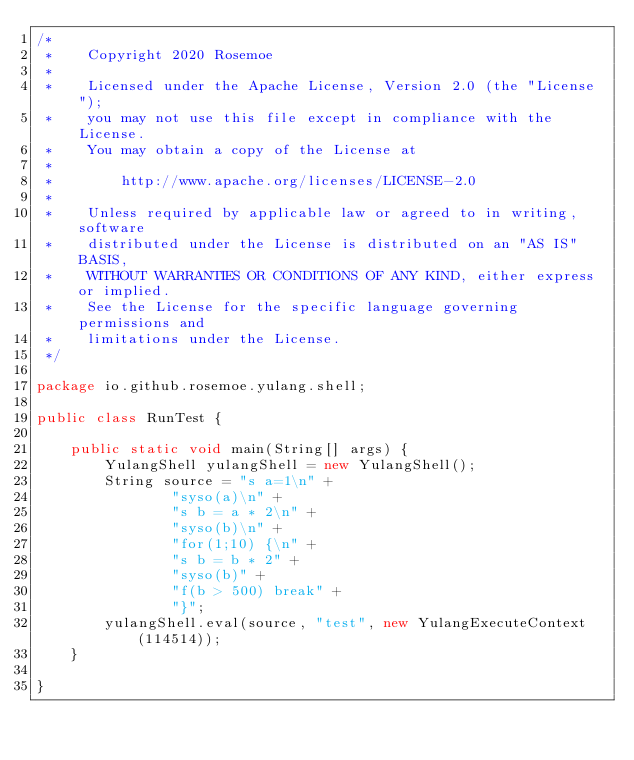<code> <loc_0><loc_0><loc_500><loc_500><_Java_>/*
 *    Copyright 2020 Rosemoe
 *
 *    Licensed under the Apache License, Version 2.0 (the "License");
 *    you may not use this file except in compliance with the License.
 *    You may obtain a copy of the License at
 *
 *        http://www.apache.org/licenses/LICENSE-2.0
 *
 *    Unless required by applicable law or agreed to in writing, software
 *    distributed under the License is distributed on an "AS IS" BASIS,
 *    WITHOUT WARRANTIES OR CONDITIONS OF ANY KIND, either express or implied.
 *    See the License for the specific language governing permissions and
 *    limitations under the License.
 */

package io.github.rosemoe.yulang.shell;

public class RunTest {

    public static void main(String[] args) {
        YulangShell yulangShell = new YulangShell();
        String source = "s a=1\n" +
                "syso(a)\n" +
                "s b = a * 2\n" +
                "syso(b)\n" +
                "for(1;10) {\n" +
                "s b = b * 2" +
                "syso(b)" +
                "f(b > 500) break" +
                "}";
        yulangShell.eval(source, "test", new YulangExecuteContext(114514));
    }

}
</code> 